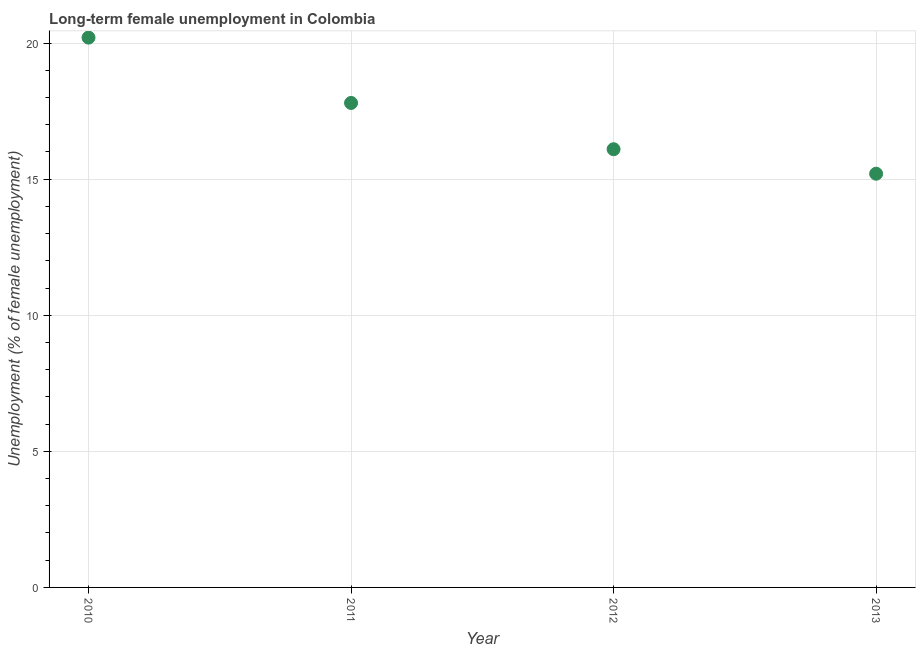What is the long-term female unemployment in 2012?
Keep it short and to the point. 16.1. Across all years, what is the maximum long-term female unemployment?
Ensure brevity in your answer.  20.2. Across all years, what is the minimum long-term female unemployment?
Offer a terse response. 15.2. What is the sum of the long-term female unemployment?
Your response must be concise. 69.3. What is the difference between the long-term female unemployment in 2011 and 2012?
Your response must be concise. 1.7. What is the average long-term female unemployment per year?
Give a very brief answer. 17.33. What is the median long-term female unemployment?
Provide a short and direct response. 16.95. In how many years, is the long-term female unemployment greater than 15 %?
Offer a terse response. 4. What is the ratio of the long-term female unemployment in 2010 to that in 2012?
Give a very brief answer. 1.25. Is the long-term female unemployment in 2010 less than that in 2012?
Offer a terse response. No. Is the difference between the long-term female unemployment in 2010 and 2013 greater than the difference between any two years?
Your answer should be compact. Yes. What is the difference between the highest and the second highest long-term female unemployment?
Ensure brevity in your answer.  2.4. Is the sum of the long-term female unemployment in 2011 and 2013 greater than the maximum long-term female unemployment across all years?
Provide a succinct answer. Yes. What is the difference between the highest and the lowest long-term female unemployment?
Keep it short and to the point. 5. In how many years, is the long-term female unemployment greater than the average long-term female unemployment taken over all years?
Ensure brevity in your answer.  2. How many years are there in the graph?
Offer a very short reply. 4. What is the difference between two consecutive major ticks on the Y-axis?
Your answer should be compact. 5. Are the values on the major ticks of Y-axis written in scientific E-notation?
Keep it short and to the point. No. What is the title of the graph?
Make the answer very short. Long-term female unemployment in Colombia. What is the label or title of the Y-axis?
Ensure brevity in your answer.  Unemployment (% of female unemployment). What is the Unemployment (% of female unemployment) in 2010?
Your answer should be very brief. 20.2. What is the Unemployment (% of female unemployment) in 2011?
Keep it short and to the point. 17.8. What is the Unemployment (% of female unemployment) in 2012?
Keep it short and to the point. 16.1. What is the Unemployment (% of female unemployment) in 2013?
Provide a succinct answer. 15.2. What is the difference between the Unemployment (% of female unemployment) in 2010 and 2011?
Make the answer very short. 2.4. What is the difference between the Unemployment (% of female unemployment) in 2010 and 2013?
Offer a terse response. 5. What is the difference between the Unemployment (% of female unemployment) in 2011 and 2012?
Provide a short and direct response. 1.7. What is the difference between the Unemployment (% of female unemployment) in 2011 and 2013?
Give a very brief answer. 2.6. What is the difference between the Unemployment (% of female unemployment) in 2012 and 2013?
Make the answer very short. 0.9. What is the ratio of the Unemployment (% of female unemployment) in 2010 to that in 2011?
Make the answer very short. 1.14. What is the ratio of the Unemployment (% of female unemployment) in 2010 to that in 2012?
Offer a very short reply. 1.25. What is the ratio of the Unemployment (% of female unemployment) in 2010 to that in 2013?
Your answer should be compact. 1.33. What is the ratio of the Unemployment (% of female unemployment) in 2011 to that in 2012?
Make the answer very short. 1.11. What is the ratio of the Unemployment (% of female unemployment) in 2011 to that in 2013?
Keep it short and to the point. 1.17. What is the ratio of the Unemployment (% of female unemployment) in 2012 to that in 2013?
Offer a terse response. 1.06. 